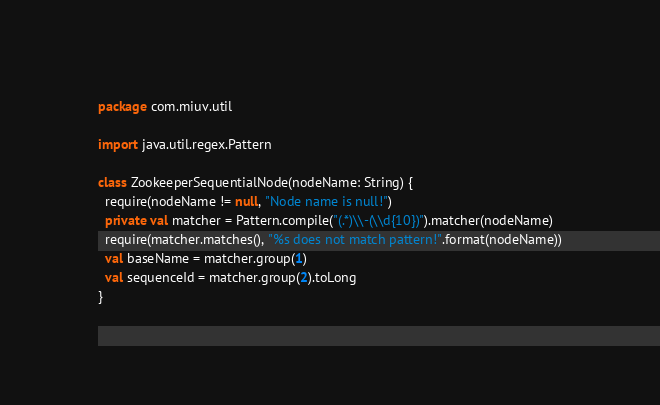<code> <loc_0><loc_0><loc_500><loc_500><_Scala_>package com.miuv.util

import java.util.regex.Pattern

class ZookeeperSequentialNode(nodeName: String) {
  require(nodeName != null, "Node name is null!")
  private val matcher = Pattern.compile("(.*)\\-(\\d{10})").matcher(nodeName)
  require(matcher.matches(), "%s does not match pattern!".format(nodeName))
  val baseName = matcher.group(1)
  val sequenceId = matcher.group(2).toLong
}
</code> 